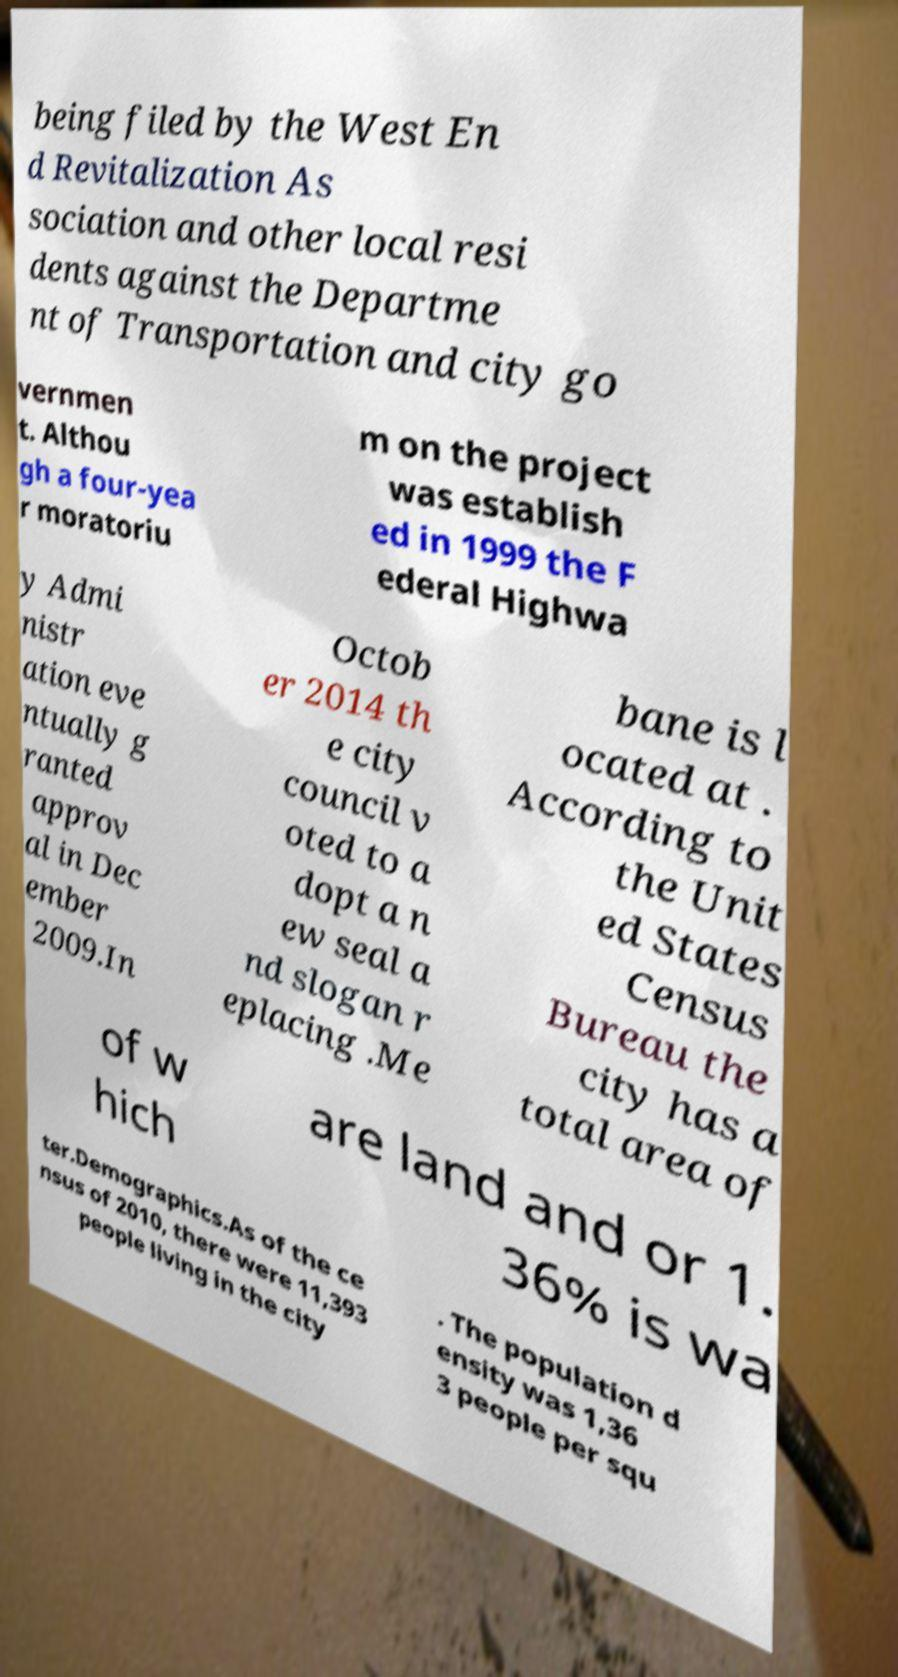Can you read and provide the text displayed in the image?This photo seems to have some interesting text. Can you extract and type it out for me? being filed by the West En d Revitalization As sociation and other local resi dents against the Departme nt of Transportation and city go vernmen t. Althou gh a four-yea r moratoriu m on the project was establish ed in 1999 the F ederal Highwa y Admi nistr ation eve ntually g ranted approv al in Dec ember 2009.In Octob er 2014 th e city council v oted to a dopt a n ew seal a nd slogan r eplacing .Me bane is l ocated at . According to the Unit ed States Census Bureau the city has a total area of of w hich are land and or 1. 36% is wa ter.Demographics.As of the ce nsus of 2010, there were 11,393 people living in the city . The population d ensity was 1,36 3 people per squ 